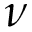Convert formula to latex. <formula><loc_0><loc_0><loc_500><loc_500>\nu</formula> 